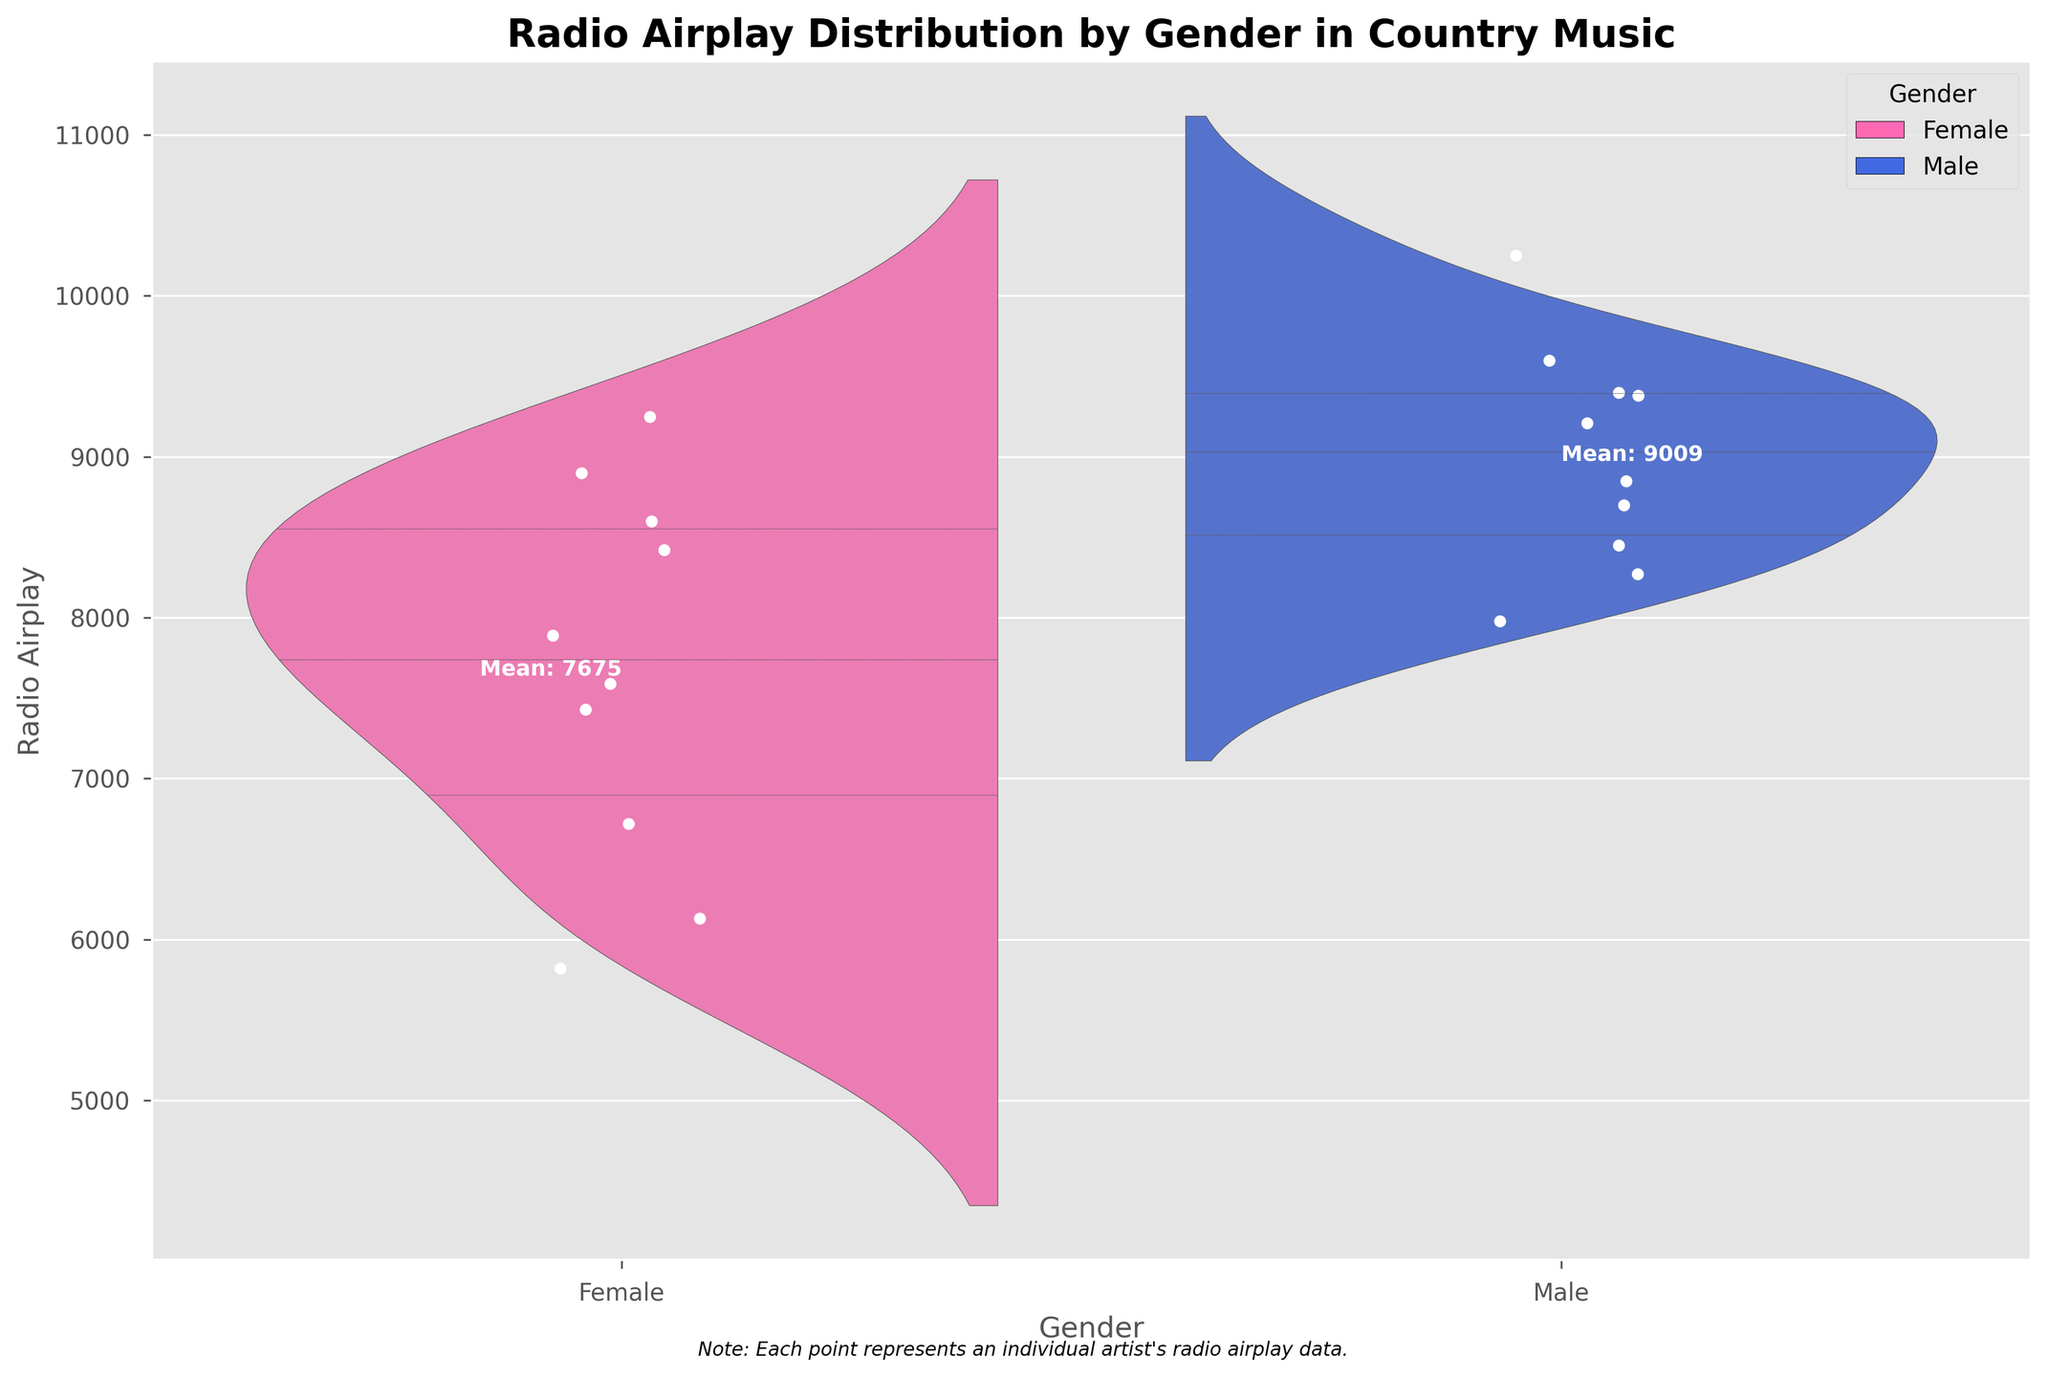What's the title of the plot? The title is written at the top of the plot in bold and larger font size.
Answer: Radio Airplay Distribution by Gender in Country Music How many points represent female artists? The plot shows each artist as a scatter point, and the total number of points for female artists can be counted directly.
Answer: 10 What color represents the male artists in the plot? The key on the plot uses a blue shade to denote male artists.
Answer: Blue What is the difference in mean radio airplay between male and female artists? The mean values for radio airplay are annotated on the plot for both genders. Subtract the mean for females from the mean for males.
Answer: Approximately 1090 Are the violin plots symmetrical for both genders? By looking at the shape of the violin plots for each gender, it appears that the distributions are not symmetrical due to differing density spreads.
Answer: No Which gender has a higher maximum value for radio airplay? Identify the highest point of the distribution for each gender from the plot. Male artists have a peak towards the upper end of the Y-axis.
Answer: Male How does Patsy Cline compare to other female artists in terms of radio airplay? Locate the dot corresponding to Patsy Cline (indicated by its position relative to other points in the female section), noting her radio airplay value and comparing it within the same group.
Answer: Higher than many, but not the highest Is there a significant overlap in radio airplay distribution between male and female artists? Compare the spread and density of the violin plots; significant overlapping areas indicate similar distributions.
Answer: Yes What is the mean radio airplay value for female artists? The plot provides this information via annotations next to each violin plot.
Answer: Approximately 7597 Which gender shows a wider range of radio airplay values? Observe the Y-axis range covered by each violin plot; male artists show a broader spread compared to female artists.
Answer: Male 